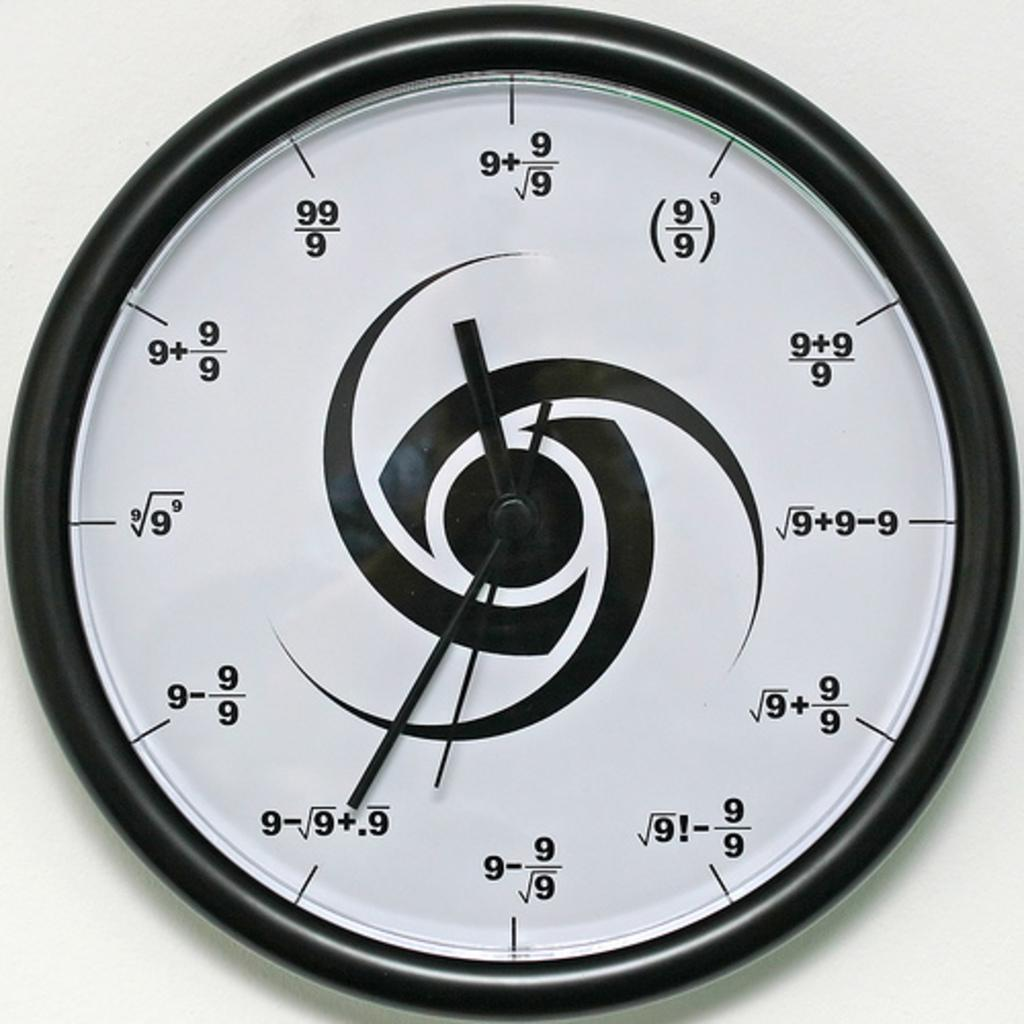<image>
Present a compact description of the photo's key features. A clock displays the time incriments in fraction, such as 9 + 9/9. 